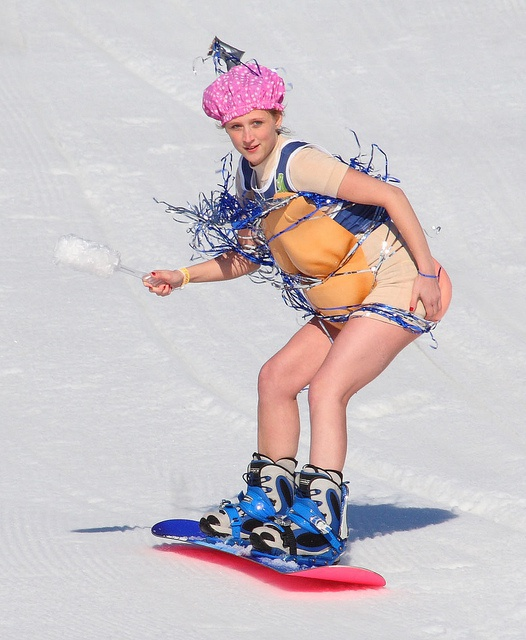Describe the objects in this image and their specific colors. I can see people in lightgray, salmon, and tan tones, snowboard in lightgray, salmon, brown, and blue tones, and snowboard in lightgray, navy, darkblue, blue, and gray tones in this image. 